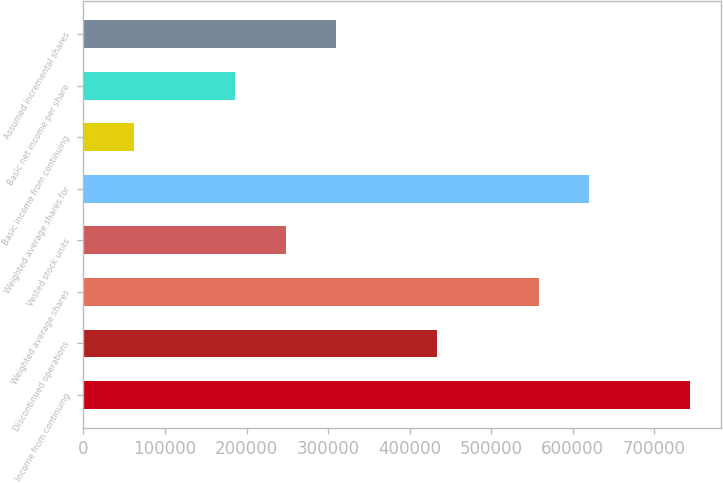Convert chart to OTSL. <chart><loc_0><loc_0><loc_500><loc_500><bar_chart><fcel>Income from continuing<fcel>Discontinued operations<fcel>Weighted average shares<fcel>Vested stock units<fcel>Weighted average shares for<fcel>Basic income from continuing<fcel>Basic net income per share<fcel>Assumed incremental shares<nl><fcel>744236<fcel>434139<fcel>558178<fcel>248081<fcel>620197<fcel>62022.3<fcel>186061<fcel>310100<nl></chart> 